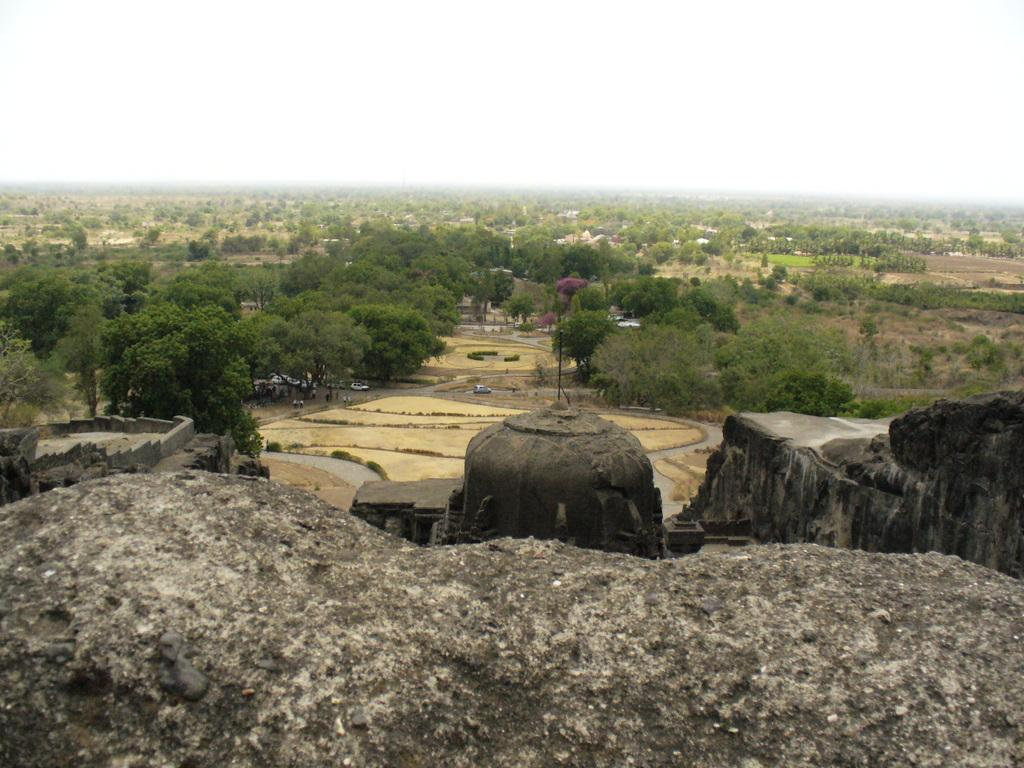What type of natural elements can be seen in the image? There are trees and rocks in the image. What is visible in the background of the image? The sky is visible in the background of the image. What type of finger can be seen in the image? There are no fingers present in the image; it features trees, rocks, and the sky. What type of company is depicted in the image? There is no company depicted in the image; it features trees, rocks, and the sky. 